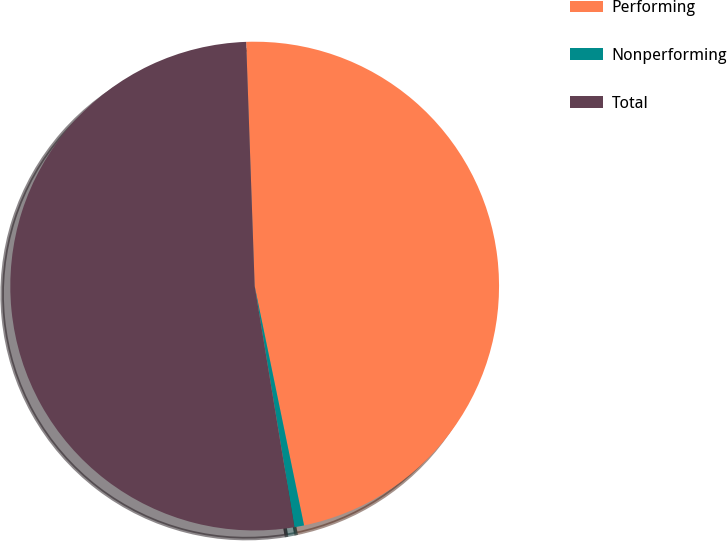Convert chart to OTSL. <chart><loc_0><loc_0><loc_500><loc_500><pie_chart><fcel>Performing<fcel>Nonperforming<fcel>Total<nl><fcel>47.31%<fcel>0.64%<fcel>52.04%<nl></chart> 